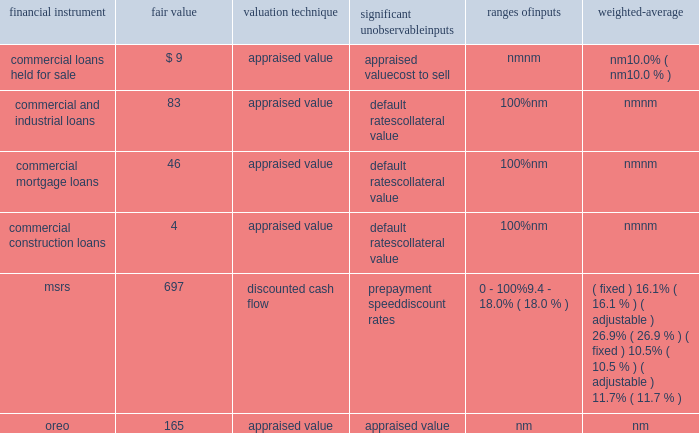Notes to consolidated financial statements 161 fifth third bancorp as of december 31 , 2012 ( $ in millions ) significant unobservable ranges of financial instrument fair value valuation technique inputs inputs weighted-average commercial loans held for sale $ 9 appraised value appraised value nm nm cost to sell nm 10.0% ( 10.0 % ) commercial and industrial loans 83 appraised value default rates 100% ( 100 % ) nm collateral value nm nm commercial mortgage loans 46 appraised value default rates 100% ( 100 % ) nm collateral value nm nm commercial construction loans 4 appraised value default rates 100% ( 100 % ) nm collateral value nm nm msrs 697 discounted cash flow prepayment speed 0 - 100% ( 100 % ) ( fixed ) 16.1% ( 16.1 % ) ( adjustable ) 26.9% ( 26.9 % ) discount rates 9.4 - 18.0% ( 18.0 % ) ( fixed ) 10.5% ( 10.5 % ) ( adjustable ) 11.7% ( 11.7 % ) .
Commercial loans held for sale during 2013 and 2012 , the bancorp transferred $ 5 million and $ 16 million , respectively , of commercial loans from the portfolio to loans held for sale that upon transfer were measured at fair value using significant unobservable inputs .
These loans had fair value adjustments in 2013 and 2012 totaling $ 4 million and $ 1 million , respectively , and were generally based on appraisals of the underlying collateral and were therefore , classified within level 3 of the valuation hierarchy .
Additionally , during 2013 and 2012 there were fair value adjustments on existing commercial loans held for sale of $ 3 million and $ 12 million , respectively .
The fair value adjustments were also based on appraisals of the underlying collateral and were therefore classified within level 3 of the valuation hierarchy .
An adverse change in the fair value of the underlying collateral would result in a decrease in the fair value measurement .
The accounting department determines the procedures for valuation of commercial hfs loans which may include a comparison to recently executed transactions of similar type loans .
A monthly review of the portfolio is performed for reasonableness .
Quarterly , appraisals approaching a year old are updated and the real estate valuation group , which reports to the chief risk and credit officer , in conjunction with the commercial line of business review the third party appraisals for reasonableness .
Additionally , the commercial line of business finance department , which reports to the bancorp chief financial officer , in conjunction with accounting review all loan appraisal values , carrying values and vintages .
Commercial loans held for investment during 2013 and 2012 , the bancorp recorded nonrecurring impairment adjustments to certain commercial and industrial , commercial mortgage and commercial construction loans held for investment .
Larger commercial loans included within aggregate borrower relationship balances exceeding $ 1 million that exhibit probable or observed credit weaknesses are subject to individual review for impairment .
The bancorp considers the current value of collateral , credit quality of any guarantees , the guarantor 2019s liquidity and willingness to cooperate , the loan structure and other factors when evaluating whether an individual loan is impaired .
When the loan is collateral dependent , the fair value of the loan is generally based on the fair value of the underlying collateral supporting the loan and therefore these loans were classified within level 3 of the valuation hierarchy .
In cases where the carrying value exceeds the fair value , an impairment loss is recognized .
An adverse change in the fair value of the underlying collateral would result in a decrease in the fair value measurement .
The fair values and recognized impairment losses are reflected in the previous table .
Commercial credit risk , which reports to the chief risk and credit officer , is responsible for preparing and reviewing the fair value estimates for commercial loans held for investment .
Mortgage interest rates increased during the year ended december 31 , 2013 and the bancorp recognized a recovery of temporary impairment on servicing rights .
The bancorp recognized temporary impairments in certain classes of the msr portfolio during the year ended december 31 , 2012 and the carrying value was adjusted to the fair value .
Msrs do not trade in an active , open market with readily observable prices .
While sales of msrs do occur , the precise terms and conditions typically are not readily available .
Accordingly , the bancorp estimates the fair value of msrs using internal discounted cash flow models with certain unobservable inputs , primarily prepayment speed assumptions , discount rates and weighted average lives , resulting in a classification within level 3 of the valuation hierarchy .
Refer to note 11 for further information on the assumptions used in the valuation of the bancorp 2019s msrs .
The secondary marketing department and treasury department are responsible for determining the valuation methodology for msrs .
Representatives from secondary marketing , treasury , accounting and risk management are responsible for reviewing key assumptions used in the internal discounted cash flow model .
Two external valuations of the msr portfolio are obtained from third parties that use valuation models in order to assess the reasonableness of the internal discounted cash flow model .
Additionally , the bancorp participates in peer surveys that provide additional confirmation of the reasonableness of key assumptions utilized in the msr valuation process and the resulting msr prices .
During 2013 and 2012 , the bancorp recorded nonrecurring adjustments to certain commercial and residential real estate properties classified as oreo and measured at the lower of carrying amount or fair value .
These nonrecurring losses are primarily due to declines in real estate values of the properties recorded in oreo .
For the years ended december 31 , 2013 and 2012 , these losses include $ 19 million and $ 17 million , respectively , recorded as charge-offs , on new oreo properties transferred from loans during the respective periods and $ 26 million and $ 57 million , respectively , recorded as negative fair value adjustments on oreo in other noninterest income subsequent to their transfer from loans .
As discussed in the following paragraphs , the fair value amounts are generally based on appraisals of the property values , resulting in a .
What is the percentage change in nonrecurring losses from 2012 to 2013? 
Computations: ((19 - 17) / 17)
Answer: 0.11765. 